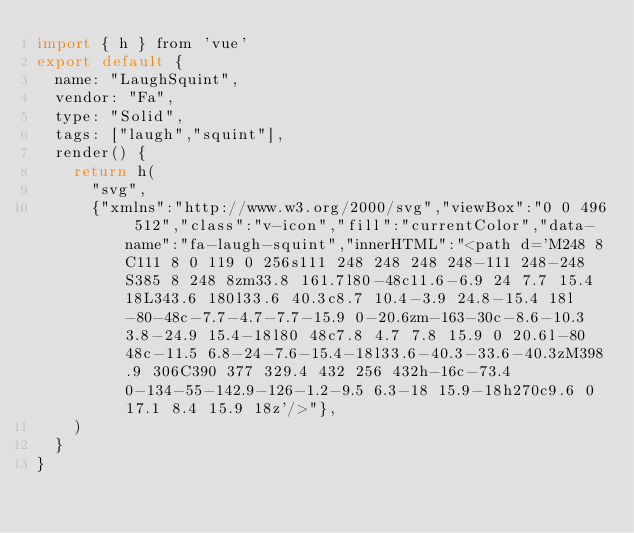<code> <loc_0><loc_0><loc_500><loc_500><_JavaScript_>import { h } from 'vue'
export default {
  name: "LaughSquint",
  vendor: "Fa",
  type: "Solid",
  tags: ["laugh","squint"],
  render() {
    return h(
      "svg",
      {"xmlns":"http://www.w3.org/2000/svg","viewBox":"0 0 496 512","class":"v-icon","fill":"currentColor","data-name":"fa-laugh-squint","innerHTML":"<path d='M248 8C111 8 0 119 0 256s111 248 248 248 248-111 248-248S385 8 248 8zm33.8 161.7l80-48c11.6-6.9 24 7.7 15.4 18L343.6 180l33.6 40.3c8.7 10.4-3.9 24.8-15.4 18l-80-48c-7.7-4.7-7.7-15.9 0-20.6zm-163-30c-8.6-10.3 3.8-24.9 15.4-18l80 48c7.8 4.7 7.8 15.9 0 20.6l-80 48c-11.5 6.8-24-7.6-15.4-18l33.6-40.3-33.6-40.3zM398.9 306C390 377 329.4 432 256 432h-16c-73.4 0-134-55-142.9-126-1.2-9.5 6.3-18 15.9-18h270c9.6 0 17.1 8.4 15.9 18z'/>"},
    )
  }
}</code> 